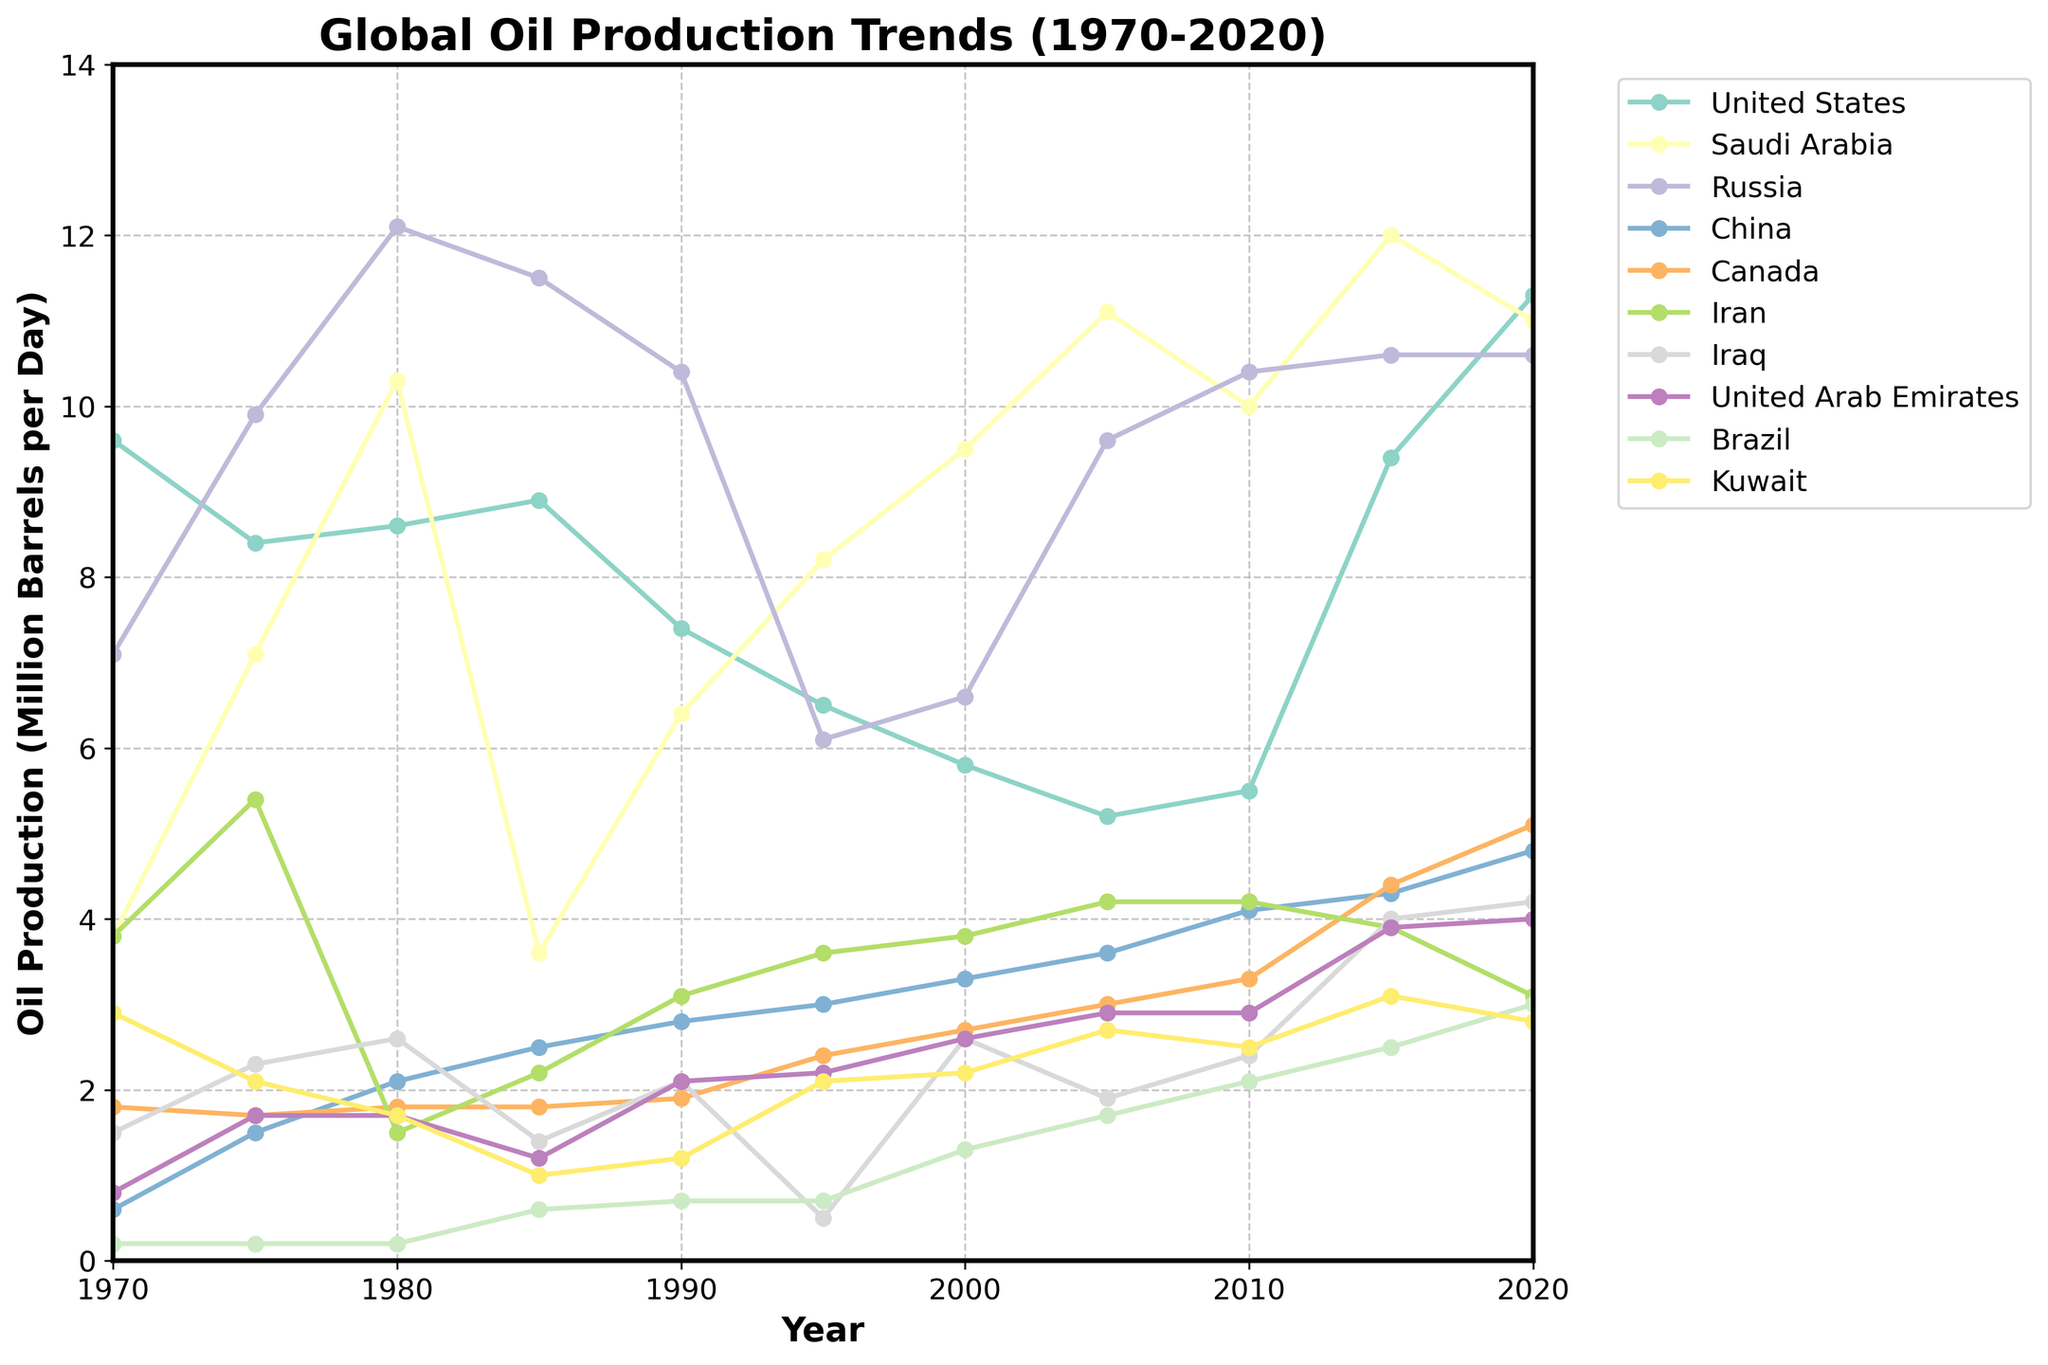What was the oil production of the United States in 1970 compared to 2020? In 1970, the United States' production was 9.6 million barrels per day, which increased to 11.3 million barrels per day by 2020. We subtract the production in 1970 from that in 2020: 11.3 - 9.6 = 1.7 million barrels per day.
Answer: 1.7 million barrels per day Which country had the highest oil production in 1980, and how much was it? By examining the lines on the graph for 1980, we see that Russia had the highest production, which is around 12.1 million barrels per day.
Answer: Russia with 12.1 million barrels per day Did any country have a steady increase in oil production over the entire 50-year period? By analyzing the trend lines, Canada shows a steady increase from 1.8 million barrels per day in 1970 to 5.1 million barrels per day in 2020.
Answer: Canada What were the two highest and two lowest oil production countries in 2015? In 2015, Saudi Arabia and the United States had the highest productions with 12.0 and 9.4 million barrels per day, respectively. Kuwait and Brazil had the lowest productions with approximately 3.1 and 2.5 million barrels per day, respectively.
Answer: Highest: Saudi Arabia and United States. Lowest: Kuwait and Brazil Which country's oil production peaked in 1980 and declined thereafter? The United States' oil production peaked in 1980 at around 8.6 million barrels per day and declined continuously until around 2005, after which it increased again.
Answer: United States How did Iran's oil production compare between 1980 and 2015? In 1980, Iran's production was approximately 1.5 million barrels per day. By 2015, this increased to around 3.9 million barrels per day.
Answer: Increased by 2.4 million barrels per day Which countries show significant fluctuations in oil production over the years, and what are some observable changes? The United States and Saudi Arabia show significant fluctuations. The US declined from around 8.6 in 1980 to 5.2 in 2005, then increased to 11.3 by 2020. Saudi Arabia increased from 3.6 in 1985 to 12.0 in 2015, and then slightly decreased to 11.0 in 2020.
Answer: United States and Saudi Arabia In which year did Russia surpass the United States in oil production, and by approximately how much? Russia first surpassed the United States in 1975. Russia's production was around 9.9 million barrels per day, while the United States' production was around 8.4 million barrels per day, a difference of 1.5 million barrels per day.
Answer: 1975 by 1.5 million barrels per day How does the production trend of China from 1970 to 2020 look? China's oil production shows a consistent increase over the 50-year period, starting from 0.6 million barrels per day in 1970 to 4.8 million barrels per day in 2020.
Answer: Consistent increase Which countries had a decline in oil production from 2015 to 2020, and by how much? Saudi Arabia declined from 12.0 million barrels per day in 2015 to 11.0 in 2020, a decrease of 1.0 million barrels per day. Iran declined from 3.9 in 2015 to 3.1, a decrease of 0.8 million barrels per day.
Answer: Saudi Arabia by 1.0, Iran by 0.8 